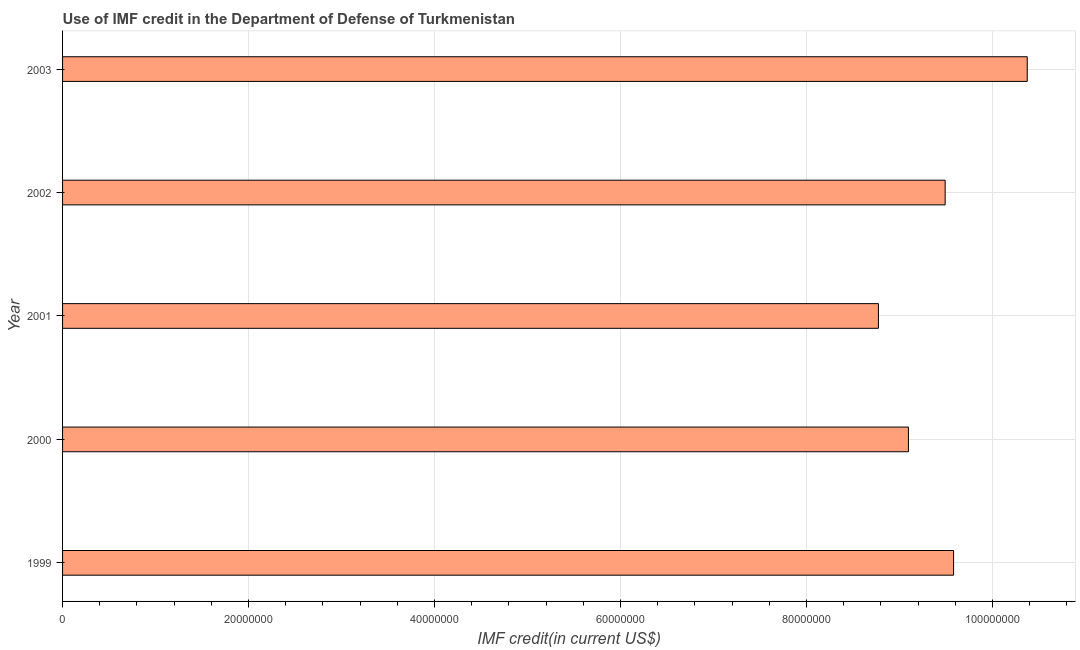Does the graph contain any zero values?
Provide a succinct answer. No. What is the title of the graph?
Your answer should be very brief. Use of IMF credit in the Department of Defense of Turkmenistan. What is the label or title of the X-axis?
Your answer should be compact. IMF credit(in current US$). What is the label or title of the Y-axis?
Your response must be concise. Year. What is the use of imf credit in dod in 2003?
Your response must be concise. 1.04e+08. Across all years, what is the maximum use of imf credit in dod?
Make the answer very short. 1.04e+08. Across all years, what is the minimum use of imf credit in dod?
Make the answer very short. 8.77e+07. In which year was the use of imf credit in dod maximum?
Make the answer very short. 2003. What is the sum of the use of imf credit in dod?
Make the answer very short. 4.73e+08. What is the difference between the use of imf credit in dod in 2001 and 2002?
Keep it short and to the point. -7.18e+06. What is the average use of imf credit in dod per year?
Your response must be concise. 9.46e+07. What is the median use of imf credit in dod?
Provide a short and direct response. 9.49e+07. In how many years, is the use of imf credit in dod greater than 28000000 US$?
Give a very brief answer. 5. What is the ratio of the use of imf credit in dod in 1999 to that in 2000?
Your answer should be very brief. 1.05. What is the difference between the highest and the second highest use of imf credit in dod?
Ensure brevity in your answer.  7.92e+06. What is the difference between the highest and the lowest use of imf credit in dod?
Give a very brief answer. 1.60e+07. What is the difference between two consecutive major ticks on the X-axis?
Your answer should be very brief. 2.00e+07. What is the IMF credit(in current US$) of 1999?
Give a very brief answer. 9.58e+07. What is the IMF credit(in current US$) of 2000?
Provide a succinct answer. 9.10e+07. What is the IMF credit(in current US$) of 2001?
Ensure brevity in your answer.  8.77e+07. What is the IMF credit(in current US$) of 2002?
Provide a succinct answer. 9.49e+07. What is the IMF credit(in current US$) of 2003?
Keep it short and to the point. 1.04e+08. What is the difference between the IMF credit(in current US$) in 1999 and 2000?
Your answer should be very brief. 4.86e+06. What is the difference between the IMF credit(in current US$) in 1999 and 2001?
Your response must be concise. 8.08e+06. What is the difference between the IMF credit(in current US$) in 1999 and 2002?
Provide a short and direct response. 9.07e+05. What is the difference between the IMF credit(in current US$) in 1999 and 2003?
Make the answer very short. -7.92e+06. What is the difference between the IMF credit(in current US$) in 2000 and 2001?
Give a very brief answer. 3.22e+06. What is the difference between the IMF credit(in current US$) in 2000 and 2002?
Ensure brevity in your answer.  -3.95e+06. What is the difference between the IMF credit(in current US$) in 2000 and 2003?
Provide a succinct answer. -1.28e+07. What is the difference between the IMF credit(in current US$) in 2001 and 2002?
Make the answer very short. -7.18e+06. What is the difference between the IMF credit(in current US$) in 2001 and 2003?
Offer a terse response. -1.60e+07. What is the difference between the IMF credit(in current US$) in 2002 and 2003?
Your response must be concise. -8.83e+06. What is the ratio of the IMF credit(in current US$) in 1999 to that in 2000?
Your answer should be compact. 1.05. What is the ratio of the IMF credit(in current US$) in 1999 to that in 2001?
Your answer should be very brief. 1.09. What is the ratio of the IMF credit(in current US$) in 1999 to that in 2003?
Your response must be concise. 0.92. What is the ratio of the IMF credit(in current US$) in 2000 to that in 2002?
Make the answer very short. 0.96. What is the ratio of the IMF credit(in current US$) in 2000 to that in 2003?
Your answer should be compact. 0.88. What is the ratio of the IMF credit(in current US$) in 2001 to that in 2002?
Your answer should be compact. 0.92. What is the ratio of the IMF credit(in current US$) in 2001 to that in 2003?
Make the answer very short. 0.85. What is the ratio of the IMF credit(in current US$) in 2002 to that in 2003?
Your answer should be compact. 0.92. 